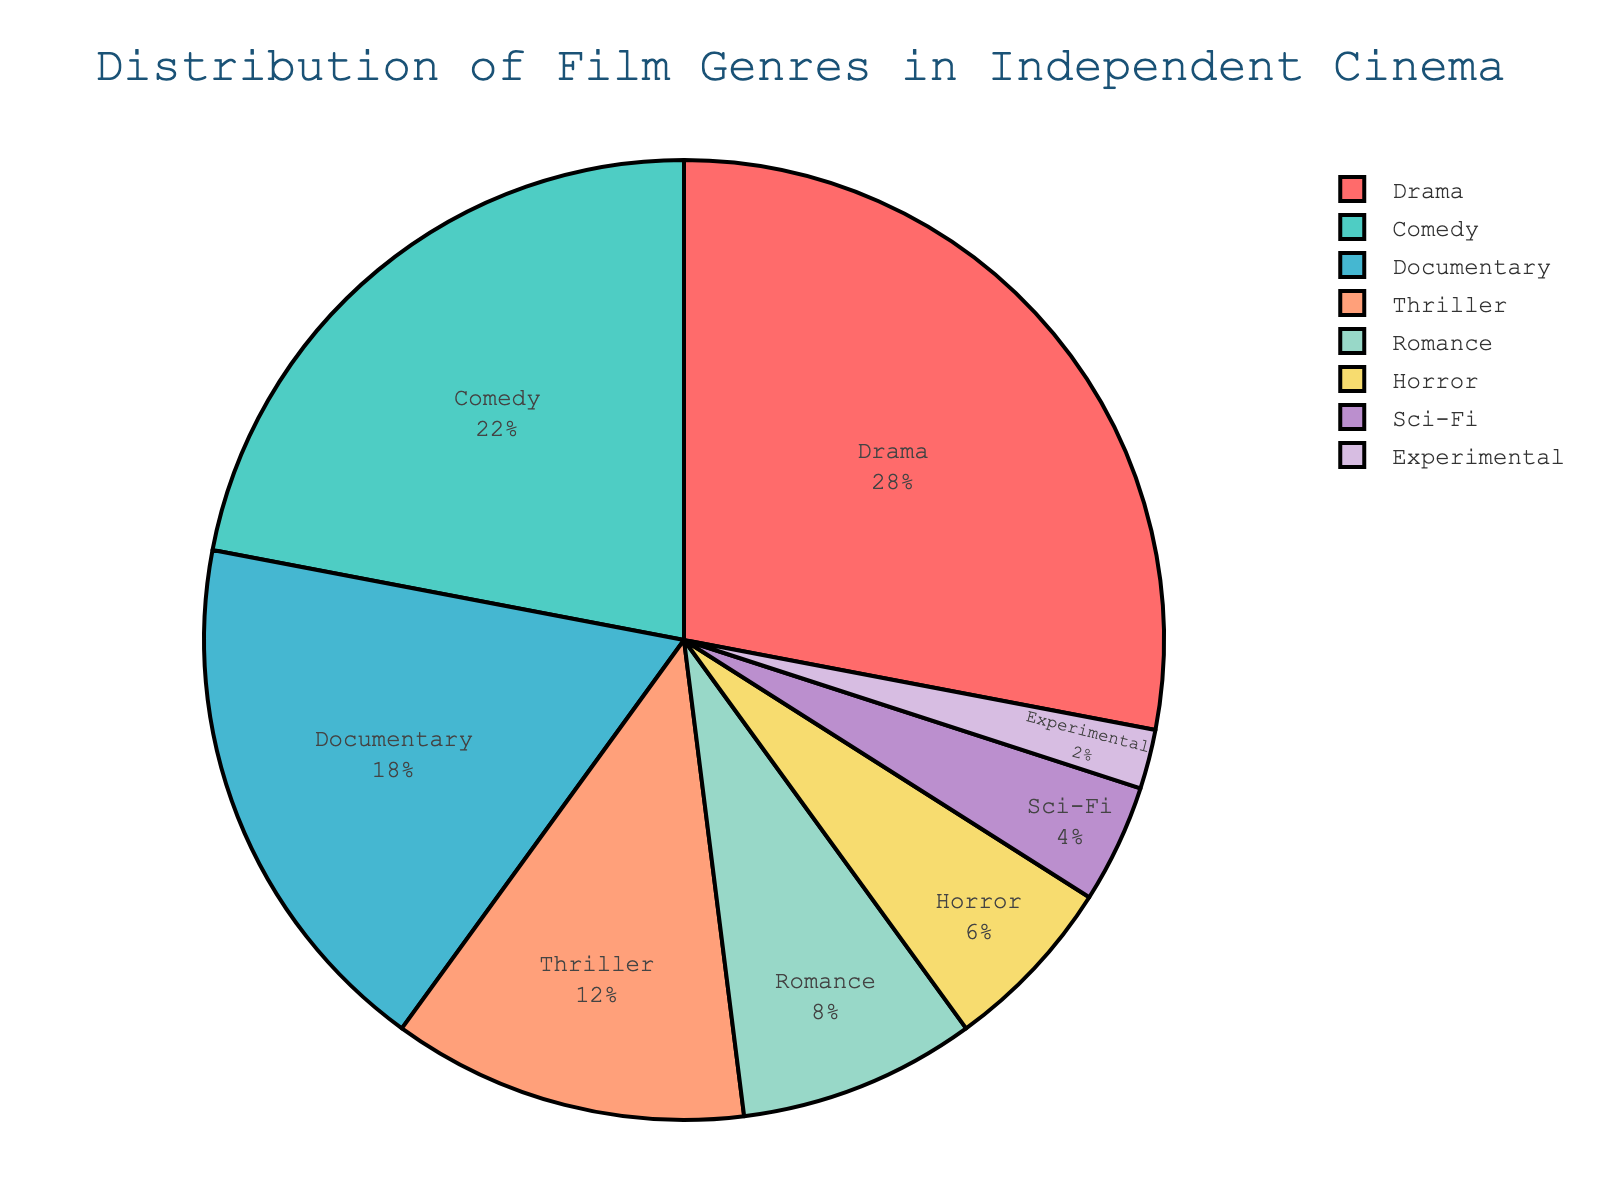What percentage of the pie chart is represented by Drama compared to Comedy? Drama represents 28% of the pie chart, and Comedy represents 22%. Comparing these percentages, Drama has a higher percentage than Comedy
Answer: Drama has a higher percentage What is the combined percentage for Documentary and Thriller genres in the pie chart? Documentary is 18%, and Thriller is 12%. Adding these together: 18% + 12% = 30%
Answer: 30% Which genre has the lowest representation in the pie chart? By inspecting the pie chart, Experimental shows the smallest slice with 2%
Answer: Experimental How does the percentage of Romance compare to Horror in the chart? Romance is 8%, and Horror is 6%. So, Romance has a higher percentage than Horror
Answer: Romance has a higher percentage What is the total percentage for Comedy, Sci-Fi, and Experimental combined? Comedy is 22%, Sci-Fi is 4%, and Experimental is 2%. Summing these: 22% + 4% + 2% = 28%
Answer: 28% What is the difference in percentage between the top two represented genres? The top two genres are Drama (28%) and Comedy (22%). The difference is 28% - 22% = 6%
Answer: 6% Which genre's segment is colored in red? The Drama segment has a red color, representing 28%
Answer: Drama What is the midpoint percentage of the genres represented by Thriller and Horror? Thriller is 12%, and Horror is 6%. The average is (12% + 6%) / 2 = 9%
Answer: 9% What percentage of the pie chart is attributed to non-fiction genres (Documentary, Experimental)? Documentary is 18%, and Experimental is 2%. Adding them yields 18% + 2% = 20%
Answer: 20% How many genres have a representation of 10% or above in the pie chart? Drama (28%), Comedy (22%), Documentary (18%), Thriller (12%) each have 10% or more. This counts up to 4 genres
Answer: 4 